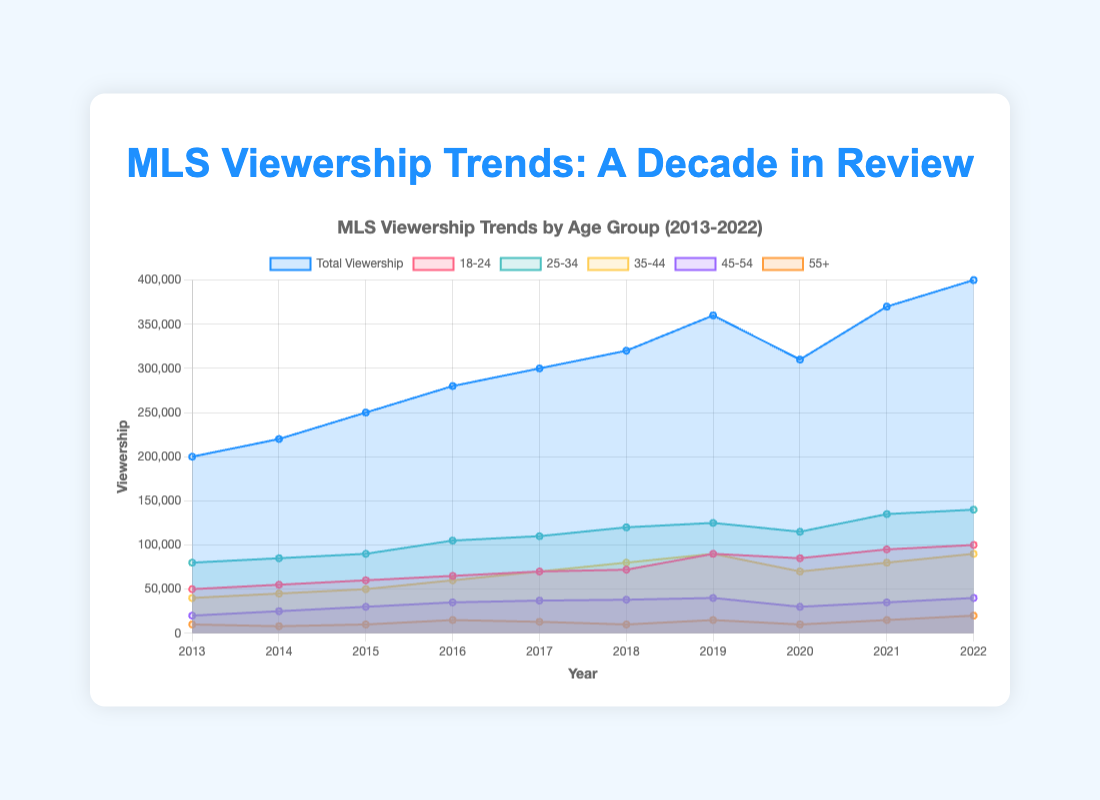What is the total viewership in 2022? To find the total viewership in 2022, look at the endpoint of the "Total Viewership" line in the chart. It shows 400,000.
Answer: 400,000 Which age group had the highest viewership in 2022? Check the endpoints of each age breakdown line for 2022. The group "25-34" has the highest value, which is 140,000.
Answer: 25-34 How did the viewership for the "18-24" age group change from 2016 to 2022? Look at the "18-24" line in the chart from 2016 and 2022. The viewership increased from 65,000 to 100,000, an increase of 35,000.
Answer: Increased by 35,000 Compare the total viewership between 2013 and 2020. Which year had more viewers? Find the total viewership values for 2013 and 2020. In 2013 it was 200,000, and in 2020 it was 310,000. Therefore, 2020 had more viewers.
Answer: 2020 What was the viewership trend for the "55+" age group from 2018 to 2020? Examine the "55+" age group's line from 2018 to 2020. The viewership decreased from 10,000 in 2018 to 10,000 in 2020, showing no change.
Answer: No change How many viewers were in the "35-44" age group in 2015? Find the data point on the "35-44" line for the year 2015. It shows 50,000 viewers.
Answer: 50,000 What was the peak viewership year for the "25-34" age group? Locate the peak of the "25-34" line, which occurs in 2022 with a viewership of 140,000.
Answer: 2022 How does the viewership for the "45-54" age group compare between 2017 and 2019? Look at the "45-54" line in 2017 and 2019. In 2017 it was 37,000, and in 2019 it was 40,000. The viewership increased by 3,000.
Answer: Increased by 3,000 What is the general trend for total viewership from 2013 to 2022? Observe the "Total Viewership" line across the years. The general trend is an increase, going from 200,000 in 2013 to 400,000 in 2022.
Answer: Increasing Which demographic had the lowest viewership in 2014? Look at all the lines for 2014 to find the lowest value. The "55+" age group had the lowest viewership with 8,000.
Answer: 55+ 